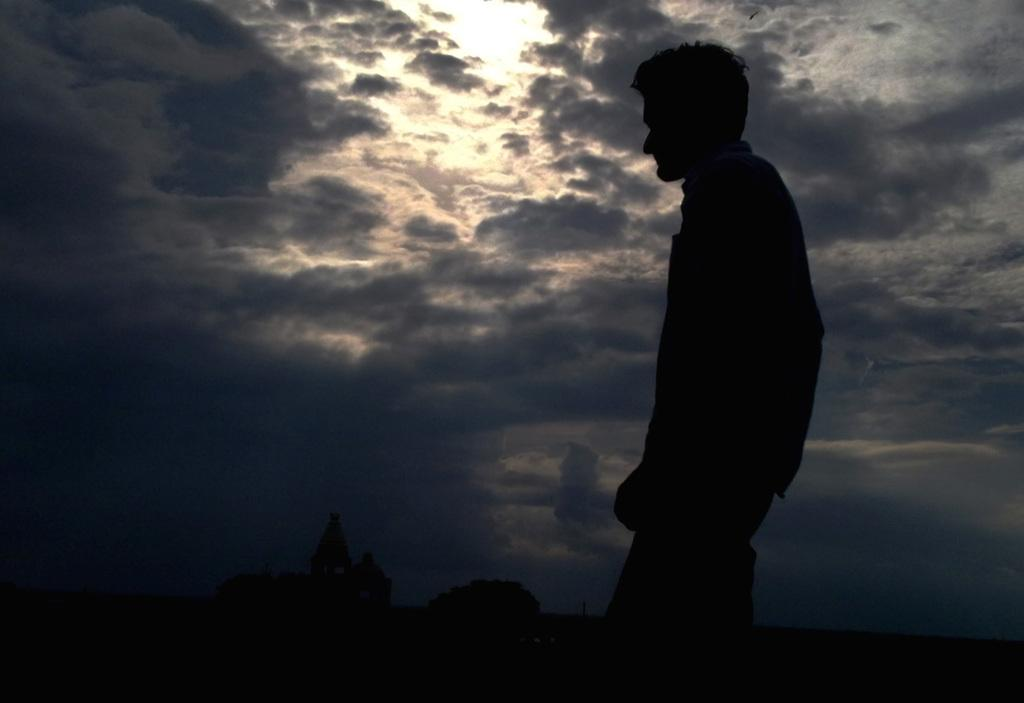Who is present in the image? There is a man in the image. What is the condition of the sky in the image? The sky is covered with clouds. What structures are at the bottom of the image? There is a building and a tree at the bottom of the image. How many birds are flying in the image? There are no birds visible in the image. What direction is the man facing in the image? The direction the man is facing cannot be determined from the image. 